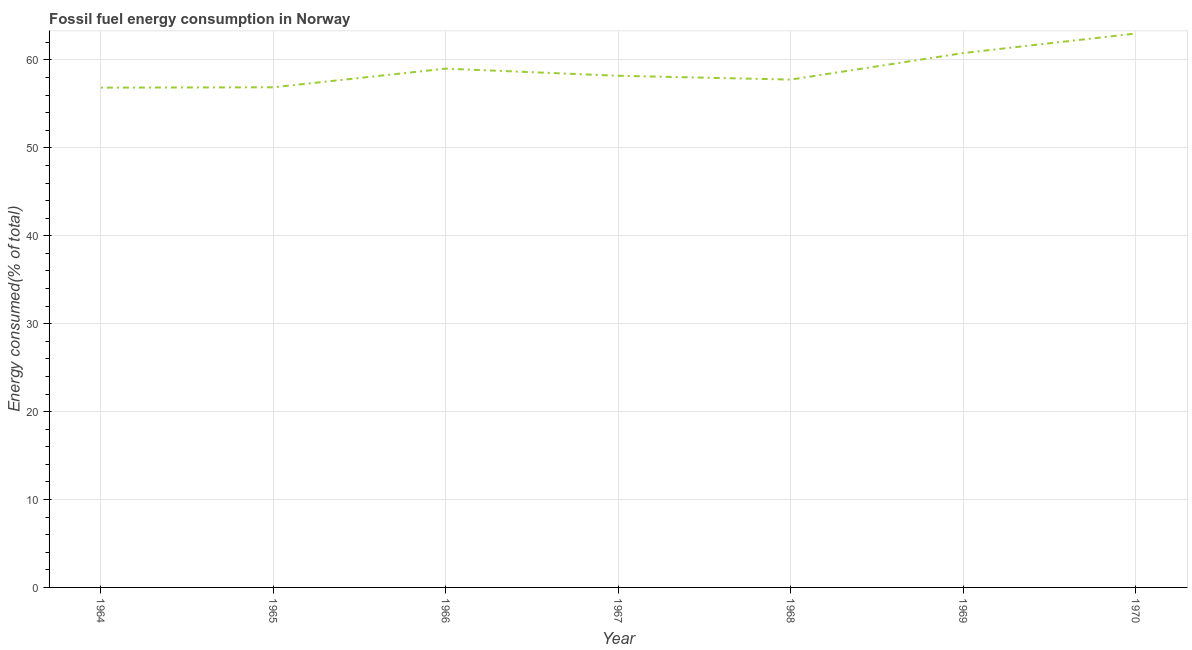What is the fossil fuel energy consumption in 1969?
Provide a succinct answer. 60.79. Across all years, what is the maximum fossil fuel energy consumption?
Give a very brief answer. 63.01. Across all years, what is the minimum fossil fuel energy consumption?
Make the answer very short. 56.86. In which year was the fossil fuel energy consumption minimum?
Ensure brevity in your answer.  1964. What is the sum of the fossil fuel energy consumption?
Keep it short and to the point. 412.55. What is the difference between the fossil fuel energy consumption in 1964 and 1966?
Offer a very short reply. -2.16. What is the average fossil fuel energy consumption per year?
Keep it short and to the point. 58.94. What is the median fossil fuel energy consumption?
Provide a short and direct response. 58.21. Do a majority of the years between 1965 and 1969 (inclusive) have fossil fuel energy consumption greater than 2 %?
Give a very brief answer. Yes. What is the ratio of the fossil fuel energy consumption in 1967 to that in 1969?
Offer a very short reply. 0.96. Is the fossil fuel energy consumption in 1966 less than that in 1969?
Your response must be concise. Yes. Is the difference between the fossil fuel energy consumption in 1964 and 1970 greater than the difference between any two years?
Keep it short and to the point. Yes. What is the difference between the highest and the second highest fossil fuel energy consumption?
Keep it short and to the point. 2.22. What is the difference between the highest and the lowest fossil fuel energy consumption?
Offer a very short reply. 6.15. In how many years, is the fossil fuel energy consumption greater than the average fossil fuel energy consumption taken over all years?
Your answer should be compact. 3. Does the fossil fuel energy consumption monotonically increase over the years?
Provide a succinct answer. No. How many years are there in the graph?
Keep it short and to the point. 7. What is the difference between two consecutive major ticks on the Y-axis?
Make the answer very short. 10. Are the values on the major ticks of Y-axis written in scientific E-notation?
Offer a very short reply. No. Does the graph contain any zero values?
Your response must be concise. No. What is the title of the graph?
Offer a very short reply. Fossil fuel energy consumption in Norway. What is the label or title of the Y-axis?
Your answer should be very brief. Energy consumed(% of total). What is the Energy consumed(% of total) of 1964?
Keep it short and to the point. 56.86. What is the Energy consumed(% of total) in 1965?
Keep it short and to the point. 56.89. What is the Energy consumed(% of total) of 1966?
Provide a succinct answer. 59.02. What is the Energy consumed(% of total) in 1967?
Make the answer very short. 58.21. What is the Energy consumed(% of total) in 1968?
Your answer should be very brief. 57.77. What is the Energy consumed(% of total) in 1969?
Offer a very short reply. 60.79. What is the Energy consumed(% of total) of 1970?
Provide a short and direct response. 63.01. What is the difference between the Energy consumed(% of total) in 1964 and 1965?
Your answer should be compact. -0.04. What is the difference between the Energy consumed(% of total) in 1964 and 1966?
Keep it short and to the point. -2.16. What is the difference between the Energy consumed(% of total) in 1964 and 1967?
Make the answer very short. -1.35. What is the difference between the Energy consumed(% of total) in 1964 and 1968?
Your answer should be compact. -0.92. What is the difference between the Energy consumed(% of total) in 1964 and 1969?
Offer a very short reply. -3.93. What is the difference between the Energy consumed(% of total) in 1964 and 1970?
Your response must be concise. -6.15. What is the difference between the Energy consumed(% of total) in 1965 and 1966?
Keep it short and to the point. -2.12. What is the difference between the Energy consumed(% of total) in 1965 and 1967?
Your answer should be very brief. -1.31. What is the difference between the Energy consumed(% of total) in 1965 and 1968?
Ensure brevity in your answer.  -0.88. What is the difference between the Energy consumed(% of total) in 1965 and 1969?
Ensure brevity in your answer.  -3.9. What is the difference between the Energy consumed(% of total) in 1965 and 1970?
Your answer should be very brief. -6.12. What is the difference between the Energy consumed(% of total) in 1966 and 1967?
Offer a very short reply. 0.81. What is the difference between the Energy consumed(% of total) in 1966 and 1968?
Your answer should be compact. 1.24. What is the difference between the Energy consumed(% of total) in 1966 and 1969?
Provide a succinct answer. -1.77. What is the difference between the Energy consumed(% of total) in 1966 and 1970?
Provide a succinct answer. -3.99. What is the difference between the Energy consumed(% of total) in 1967 and 1968?
Keep it short and to the point. 0.43. What is the difference between the Energy consumed(% of total) in 1967 and 1969?
Ensure brevity in your answer.  -2.58. What is the difference between the Energy consumed(% of total) in 1967 and 1970?
Ensure brevity in your answer.  -4.8. What is the difference between the Energy consumed(% of total) in 1968 and 1969?
Keep it short and to the point. -3.02. What is the difference between the Energy consumed(% of total) in 1968 and 1970?
Offer a very short reply. -5.24. What is the difference between the Energy consumed(% of total) in 1969 and 1970?
Provide a succinct answer. -2.22. What is the ratio of the Energy consumed(% of total) in 1964 to that in 1967?
Offer a terse response. 0.98. What is the ratio of the Energy consumed(% of total) in 1964 to that in 1969?
Keep it short and to the point. 0.94. What is the ratio of the Energy consumed(% of total) in 1964 to that in 1970?
Provide a succinct answer. 0.9. What is the ratio of the Energy consumed(% of total) in 1965 to that in 1967?
Offer a terse response. 0.98. What is the ratio of the Energy consumed(% of total) in 1965 to that in 1969?
Give a very brief answer. 0.94. What is the ratio of the Energy consumed(% of total) in 1965 to that in 1970?
Offer a very short reply. 0.9. What is the ratio of the Energy consumed(% of total) in 1966 to that in 1968?
Offer a terse response. 1.02. What is the ratio of the Energy consumed(% of total) in 1966 to that in 1969?
Provide a succinct answer. 0.97. What is the ratio of the Energy consumed(% of total) in 1966 to that in 1970?
Offer a terse response. 0.94. What is the ratio of the Energy consumed(% of total) in 1967 to that in 1968?
Your response must be concise. 1.01. What is the ratio of the Energy consumed(% of total) in 1967 to that in 1970?
Keep it short and to the point. 0.92. What is the ratio of the Energy consumed(% of total) in 1968 to that in 1969?
Provide a short and direct response. 0.95. What is the ratio of the Energy consumed(% of total) in 1968 to that in 1970?
Your answer should be compact. 0.92. What is the ratio of the Energy consumed(% of total) in 1969 to that in 1970?
Offer a very short reply. 0.96. 